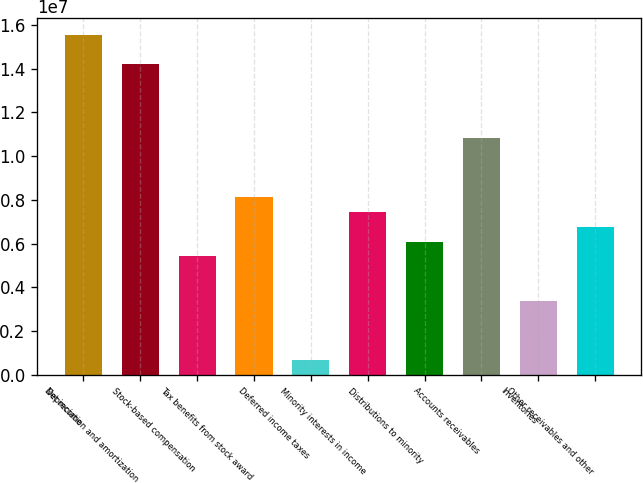Convert chart. <chart><loc_0><loc_0><loc_500><loc_500><bar_chart><fcel>Net income<fcel>Depreciation and amortization<fcel>Stock-based compensation<fcel>Tax benefits from stock award<fcel>Deferred income taxes<fcel>Minority interests in income<fcel>Distributions to minority<fcel>Accounts receivables<fcel>Inventories<fcel>Other receivables and other<nl><fcel>1.5552e+07<fcel>1.41997e+07<fcel>5.40939e+06<fcel>8.11409e+06<fcel>676176<fcel>7.43792e+06<fcel>6.08557e+06<fcel>1.08188e+07<fcel>3.38087e+06<fcel>6.76174e+06<nl></chart> 